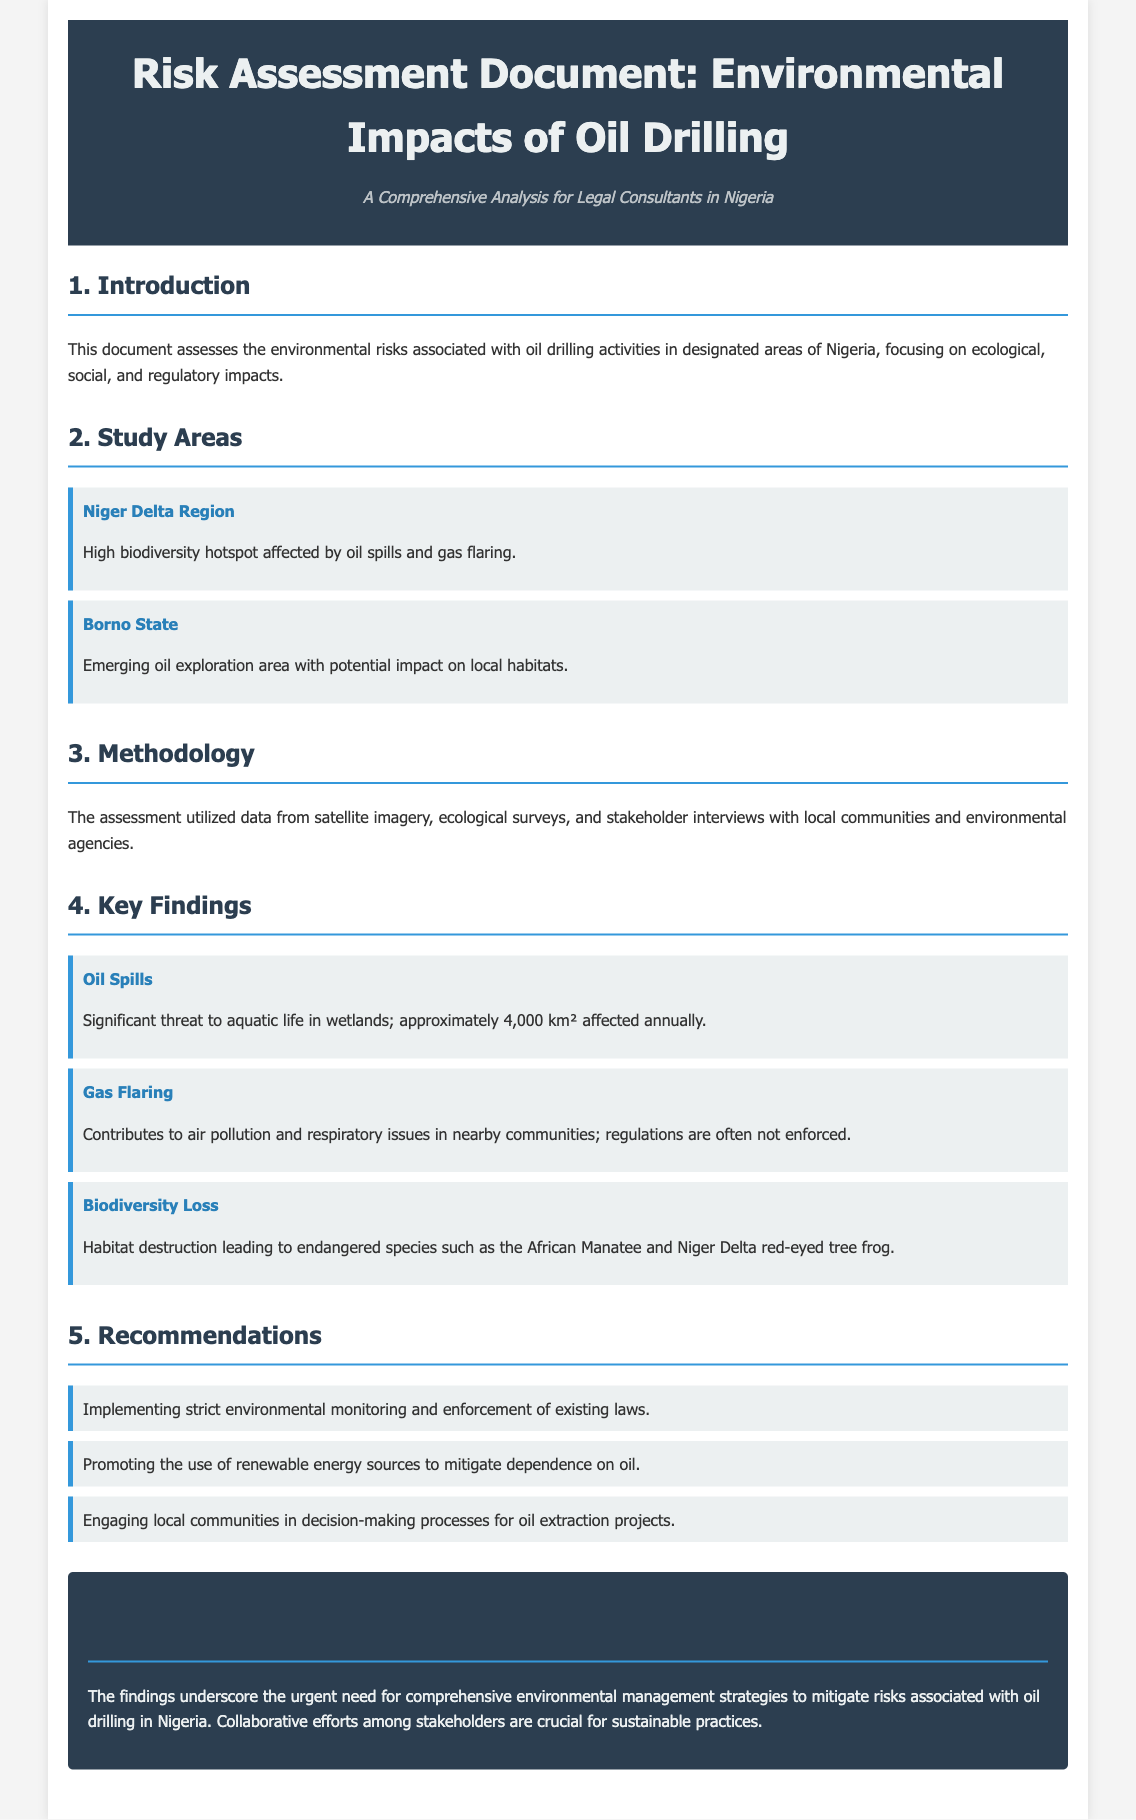What are the study areas mentioned? The document lists the study areas as the Niger Delta Region and Borno State.
Answer: Niger Delta Region, Borno State What is the main threat posed by oil spills? The document states that oil spills pose a significant threat to aquatic life in wetlands.
Answer: Aquatic life How many square kilometers are affected by oil spills annually? The assessment indicates that approximately 4,000 square kilometers are affected annually by oil spills.
Answer: 4,000 km² What contributes to respiratory issues in nearby communities? Gas flaring is mentioned as a contributor to air pollution and respiratory issues.
Answer: Gas flaring What is one of the recommendations for environmental management? One of the recommendations includes implementing strict environmental monitoring and enforcement of existing laws.
Answer: Implementing strict environmental monitoring What endangered species are mentioned? The document highlights the African Manatee and Niger Delta red-eyed tree frog as endangered species.
Answer: African Manatee, Niger Delta red-eyed tree frog Which methodology was used for the assessment? The assessment utilized data from satellite imagery, ecological surveys, and stakeholder interviews.
Answer: Satellite imagery, ecological surveys, stakeholder interviews What is the conclusion of the document? The conclusion emphasizes the need for comprehensive environmental management strategies to mitigate risks associated with oil drilling.
Answer: Urgent need for comprehensive environmental management strategies What year is this assessment relevant to? The document does not specify a particular year, but it is a comprehensive analysis for legal consultants in Nigeria, implying current relevance.
Answer: Current relevance 